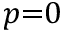<formula> <loc_0><loc_0><loc_500><loc_500>p { = } 0</formula> 